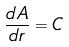<formula> <loc_0><loc_0><loc_500><loc_500>\frac { d A } { d r } = C</formula> 